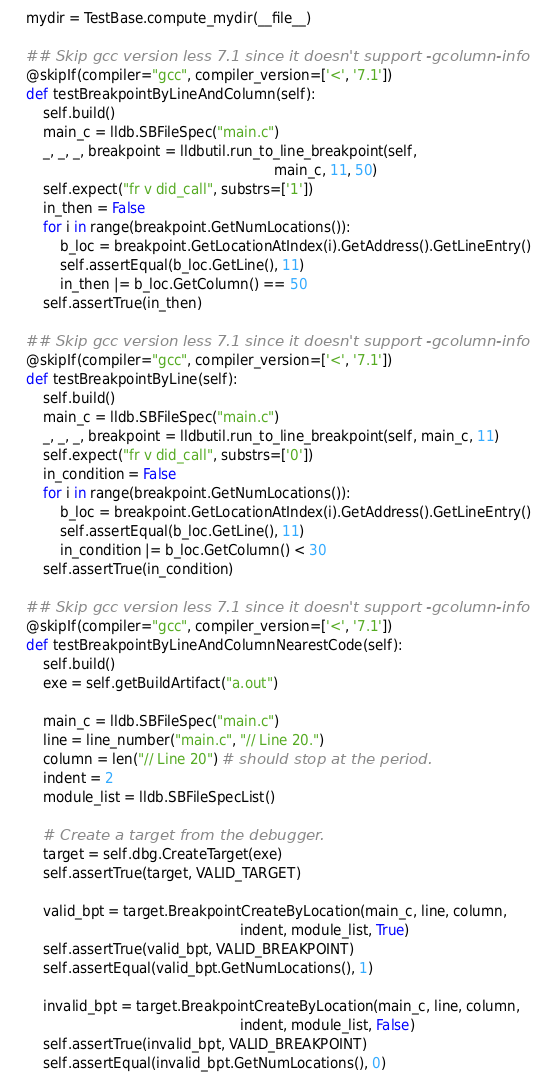Convert code to text. <code><loc_0><loc_0><loc_500><loc_500><_Python_>    mydir = TestBase.compute_mydir(__file__)

    ## Skip gcc version less 7.1 since it doesn't support -gcolumn-info
    @skipIf(compiler="gcc", compiler_version=['<', '7.1'])
    def testBreakpointByLineAndColumn(self):
        self.build()
        main_c = lldb.SBFileSpec("main.c")
        _, _, _, breakpoint = lldbutil.run_to_line_breakpoint(self,
                                                              main_c, 11, 50)
        self.expect("fr v did_call", substrs=['1'])
        in_then = False
        for i in range(breakpoint.GetNumLocations()):
            b_loc = breakpoint.GetLocationAtIndex(i).GetAddress().GetLineEntry()
            self.assertEqual(b_loc.GetLine(), 11)
            in_then |= b_loc.GetColumn() == 50
        self.assertTrue(in_then)

    ## Skip gcc version less 7.1 since it doesn't support -gcolumn-info
    @skipIf(compiler="gcc", compiler_version=['<', '7.1'])
    def testBreakpointByLine(self):
        self.build()
        main_c = lldb.SBFileSpec("main.c")
        _, _, _, breakpoint = lldbutil.run_to_line_breakpoint(self, main_c, 11)
        self.expect("fr v did_call", substrs=['0'])
        in_condition = False
        for i in range(breakpoint.GetNumLocations()):
            b_loc = breakpoint.GetLocationAtIndex(i).GetAddress().GetLineEntry()
            self.assertEqual(b_loc.GetLine(), 11)
            in_condition |= b_loc.GetColumn() < 30
        self.assertTrue(in_condition)

    ## Skip gcc version less 7.1 since it doesn't support -gcolumn-info
    @skipIf(compiler="gcc", compiler_version=['<', '7.1'])
    def testBreakpointByLineAndColumnNearestCode(self):
        self.build()
        exe = self.getBuildArtifact("a.out")

        main_c = lldb.SBFileSpec("main.c")
        line = line_number("main.c", "// Line 20.")
        column = len("// Line 20") # should stop at the period.
        indent = 2
        module_list = lldb.SBFileSpecList()

        # Create a target from the debugger.
        target = self.dbg.CreateTarget(exe)
        self.assertTrue(target, VALID_TARGET)

        valid_bpt = target.BreakpointCreateByLocation(main_c, line, column,
                                                      indent, module_list, True)
        self.assertTrue(valid_bpt, VALID_BREAKPOINT)
        self.assertEqual(valid_bpt.GetNumLocations(), 1)

        invalid_bpt = target.BreakpointCreateByLocation(main_c, line, column,
                                                      indent, module_list, False)
        self.assertTrue(invalid_bpt, VALID_BREAKPOINT)
        self.assertEqual(invalid_bpt.GetNumLocations(), 0)

</code> 